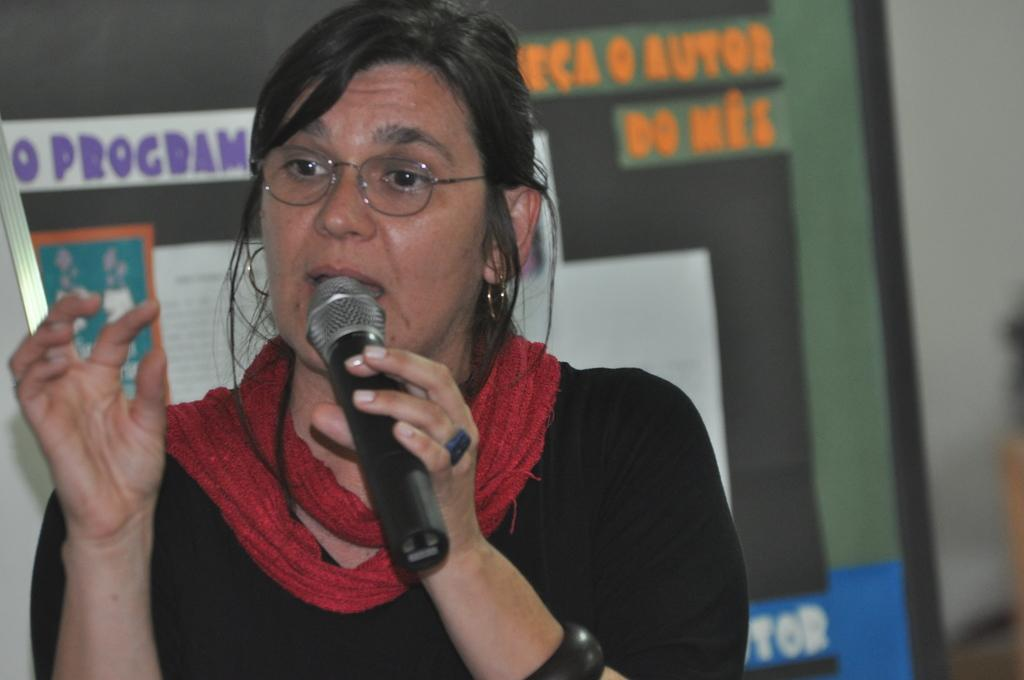Who is the main subject in the image? There is a woman in the image. What is the woman doing in the image? The woman is standing and talking. What is the woman holding in her hand? The woman is holding a microphone in her hand. What is behind the woman in the image? There is a board behind the woman. What is on the board? The board has posters and text on it. How would you describe the background of the image? The background of the image is blurred. How does the actor take a breath while delivering their lines in the image? There is no actor present in the image, and the woman is not delivering lines for a performance. 